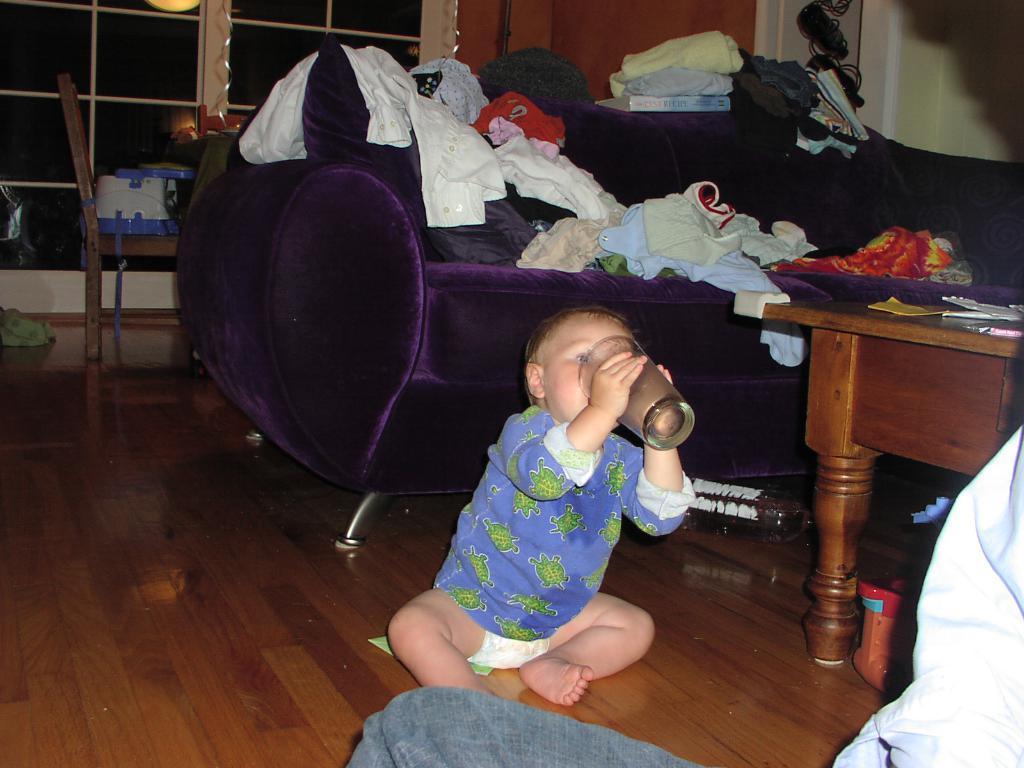Could you give a brief overview of what you see in this image? This image is clicked in a room. There is a table on the right side where it has some papers and there is a kid sitting in the middle who is drinking something from the glass. He wore blue dress ,there is a sofa in the middle of the image ,clothes are placed on the sofa and there is a chair on the left side. There are Windows backside. There is also a book placed on sofa. 